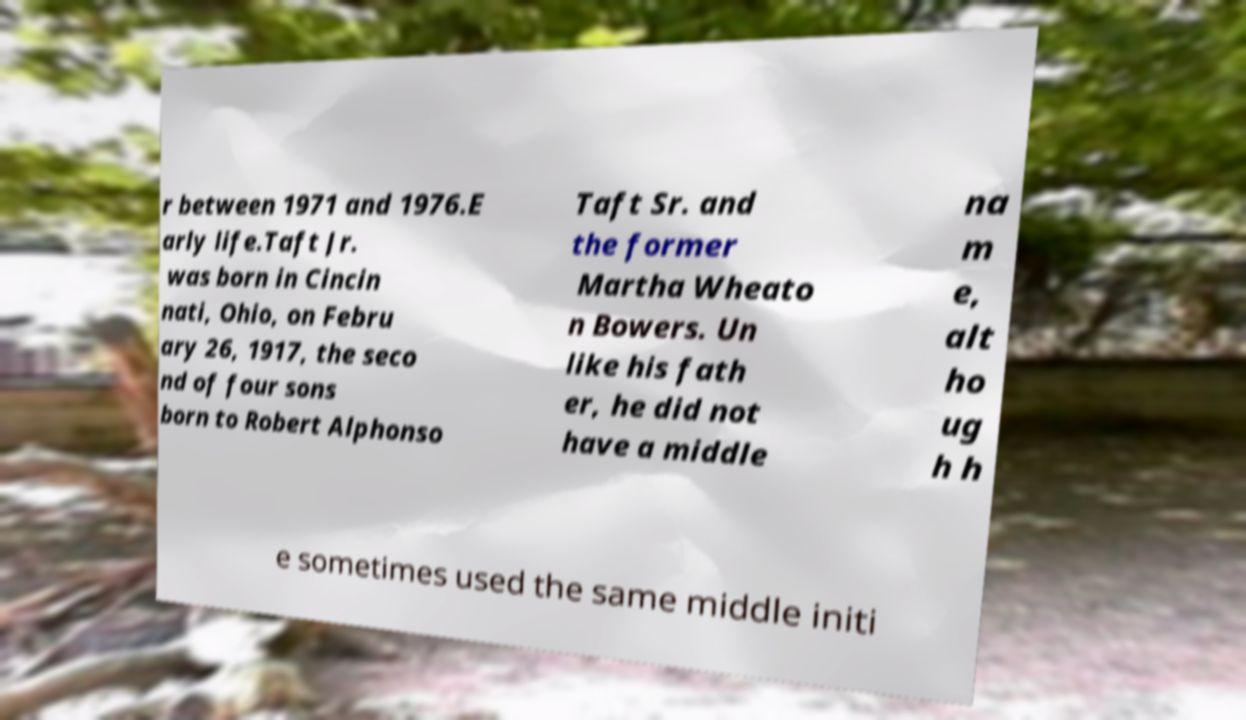For documentation purposes, I need the text within this image transcribed. Could you provide that? r between 1971 and 1976.E arly life.Taft Jr. was born in Cincin nati, Ohio, on Febru ary 26, 1917, the seco nd of four sons born to Robert Alphonso Taft Sr. and the former Martha Wheato n Bowers. Un like his fath er, he did not have a middle na m e, alt ho ug h h e sometimes used the same middle initi 